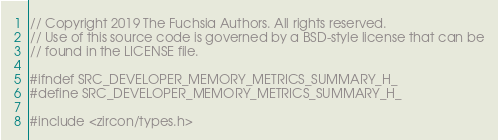Convert code to text. <code><loc_0><loc_0><loc_500><loc_500><_C_>// Copyright 2019 The Fuchsia Authors. All rights reserved.
// Use of this source code is governed by a BSD-style license that can be
// found in the LICENSE file.

#ifndef SRC_DEVELOPER_MEMORY_METRICS_SUMMARY_H_
#define SRC_DEVELOPER_MEMORY_METRICS_SUMMARY_H_

#include <zircon/types.h>
</code> 